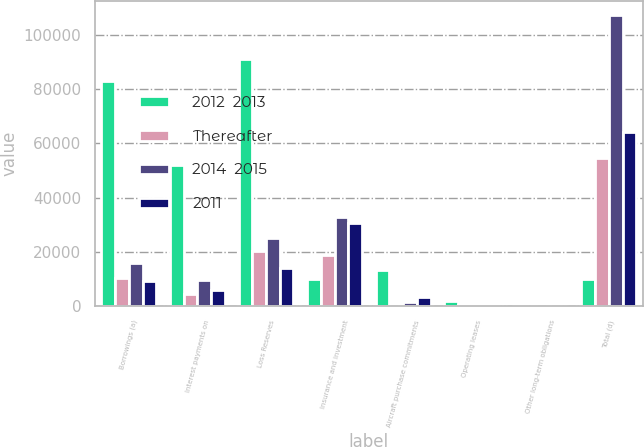<chart> <loc_0><loc_0><loc_500><loc_500><stacked_bar_chart><ecel><fcel>Borrowings (a)<fcel>Interest payments on<fcel>Loss Reserves<fcel>Insurance and investment<fcel>Aircraft purchase commitments<fcel>Operating leases<fcel>Other long-term obligations<fcel>Total (d)<nl><fcel>2012  2013<fcel>82862<fcel>51940<fcel>91151<fcel>9927.5<fcel>13533<fcel>2054<fcel>365<fcel>9927.5<nl><fcel>Thereafter<fcel>10323<fcel>4531<fcel>20235<fcel>18743<fcel>282<fcel>429<fcel>61<fcel>54604<nl><fcel>2014  2015<fcel>16031<fcel>9532<fcel>25157<fcel>32916<fcel>1742<fcel>657<fcel>95<fcel>107115<nl><fcel>2011<fcel>9223<fcel>5963<fcel>14074<fcel>30706<fcel>3523<fcel>422<fcel>80<fcel>63991<nl></chart> 